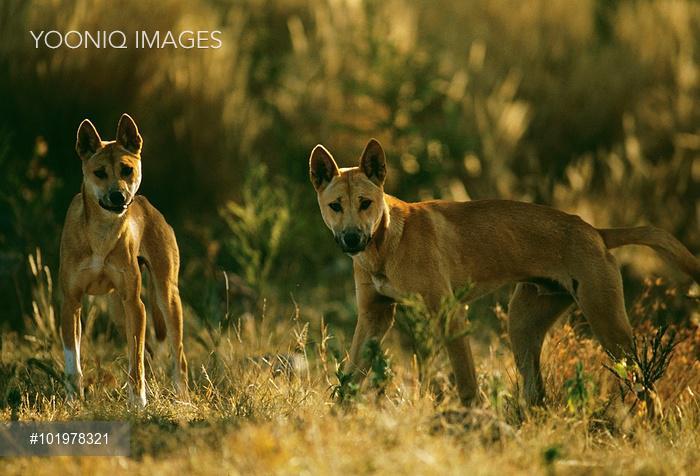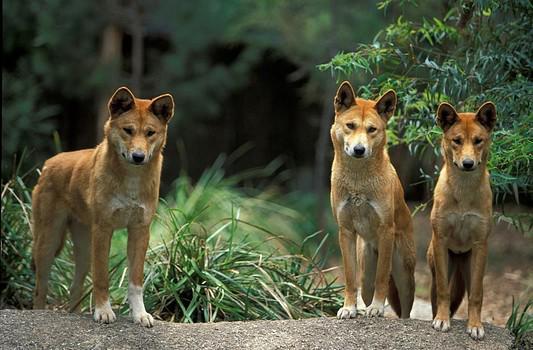The first image is the image on the left, the second image is the image on the right. Evaluate the accuracy of this statement regarding the images: "There are exactly six dogs in total.". Is it true? Answer yes or no. No. The first image is the image on the left, the second image is the image on the right. For the images displayed, is the sentence "The left image contains two dingos, with one dog's head turned left and lower than the other right-turned head, and the right image contains no dogs that are not reclining." factually correct? Answer yes or no. No. 